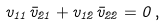Convert formula to latex. <formula><loc_0><loc_0><loc_500><loc_500>v _ { 1 1 } \bar { v } _ { 2 1 } + v _ { 1 2 } \bar { v } _ { 2 2 } = 0 \, ,</formula> 